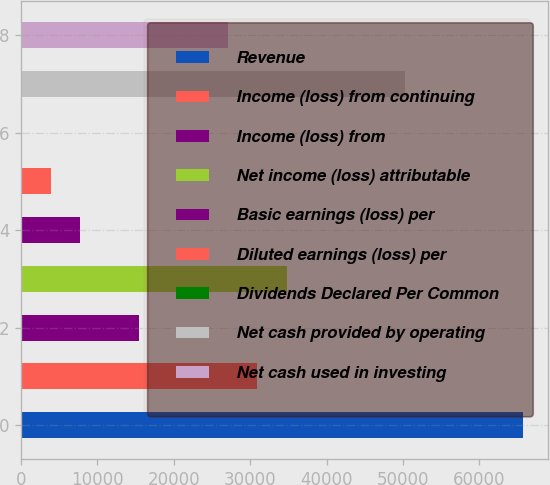<chart> <loc_0><loc_0><loc_500><loc_500><bar_chart><fcel>Revenue<fcel>Income (loss) from continuing<fcel>Income (loss) from<fcel>Net income (loss) attributable<fcel>Basic earnings (loss) per<fcel>Diluted earnings (loss) per<fcel>Dividends Declared Per Common<fcel>Net cash provided by operating<fcel>Net cash used in investing<nl><fcel>65749<fcel>30940.9<fcel>15470.6<fcel>34808.5<fcel>7735.41<fcel>3867.83<fcel>0.25<fcel>50278.7<fcel>27073.3<nl></chart> 